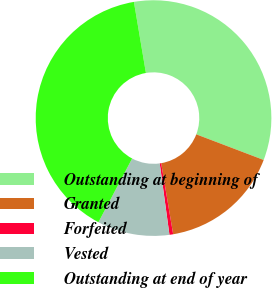Convert chart. <chart><loc_0><loc_0><loc_500><loc_500><pie_chart><fcel>Outstanding at beginning of<fcel>Granted<fcel>Forfeited<fcel>Vested<fcel>Outstanding at end of year<nl><fcel>33.45%<fcel>16.55%<fcel>0.51%<fcel>9.9%<fcel>39.59%<nl></chart> 